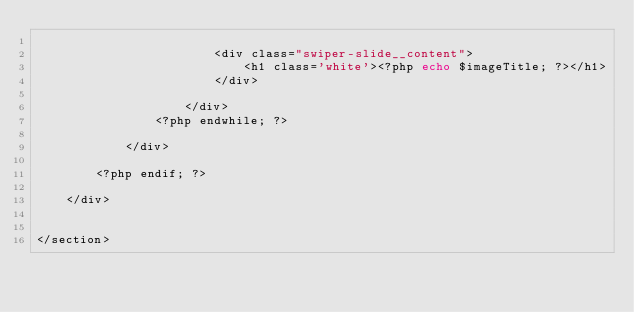Convert code to text. <code><loc_0><loc_0><loc_500><loc_500><_PHP_>
                        <div class="swiper-slide__content">
                            <h1 class='white'><?php echo $imageTitle; ?></h1>
                        </div>
            
                    </div>
                <?php endwhile; ?>

            </div>

        <?php endif; ?>

    </div>


</section>


</code> 